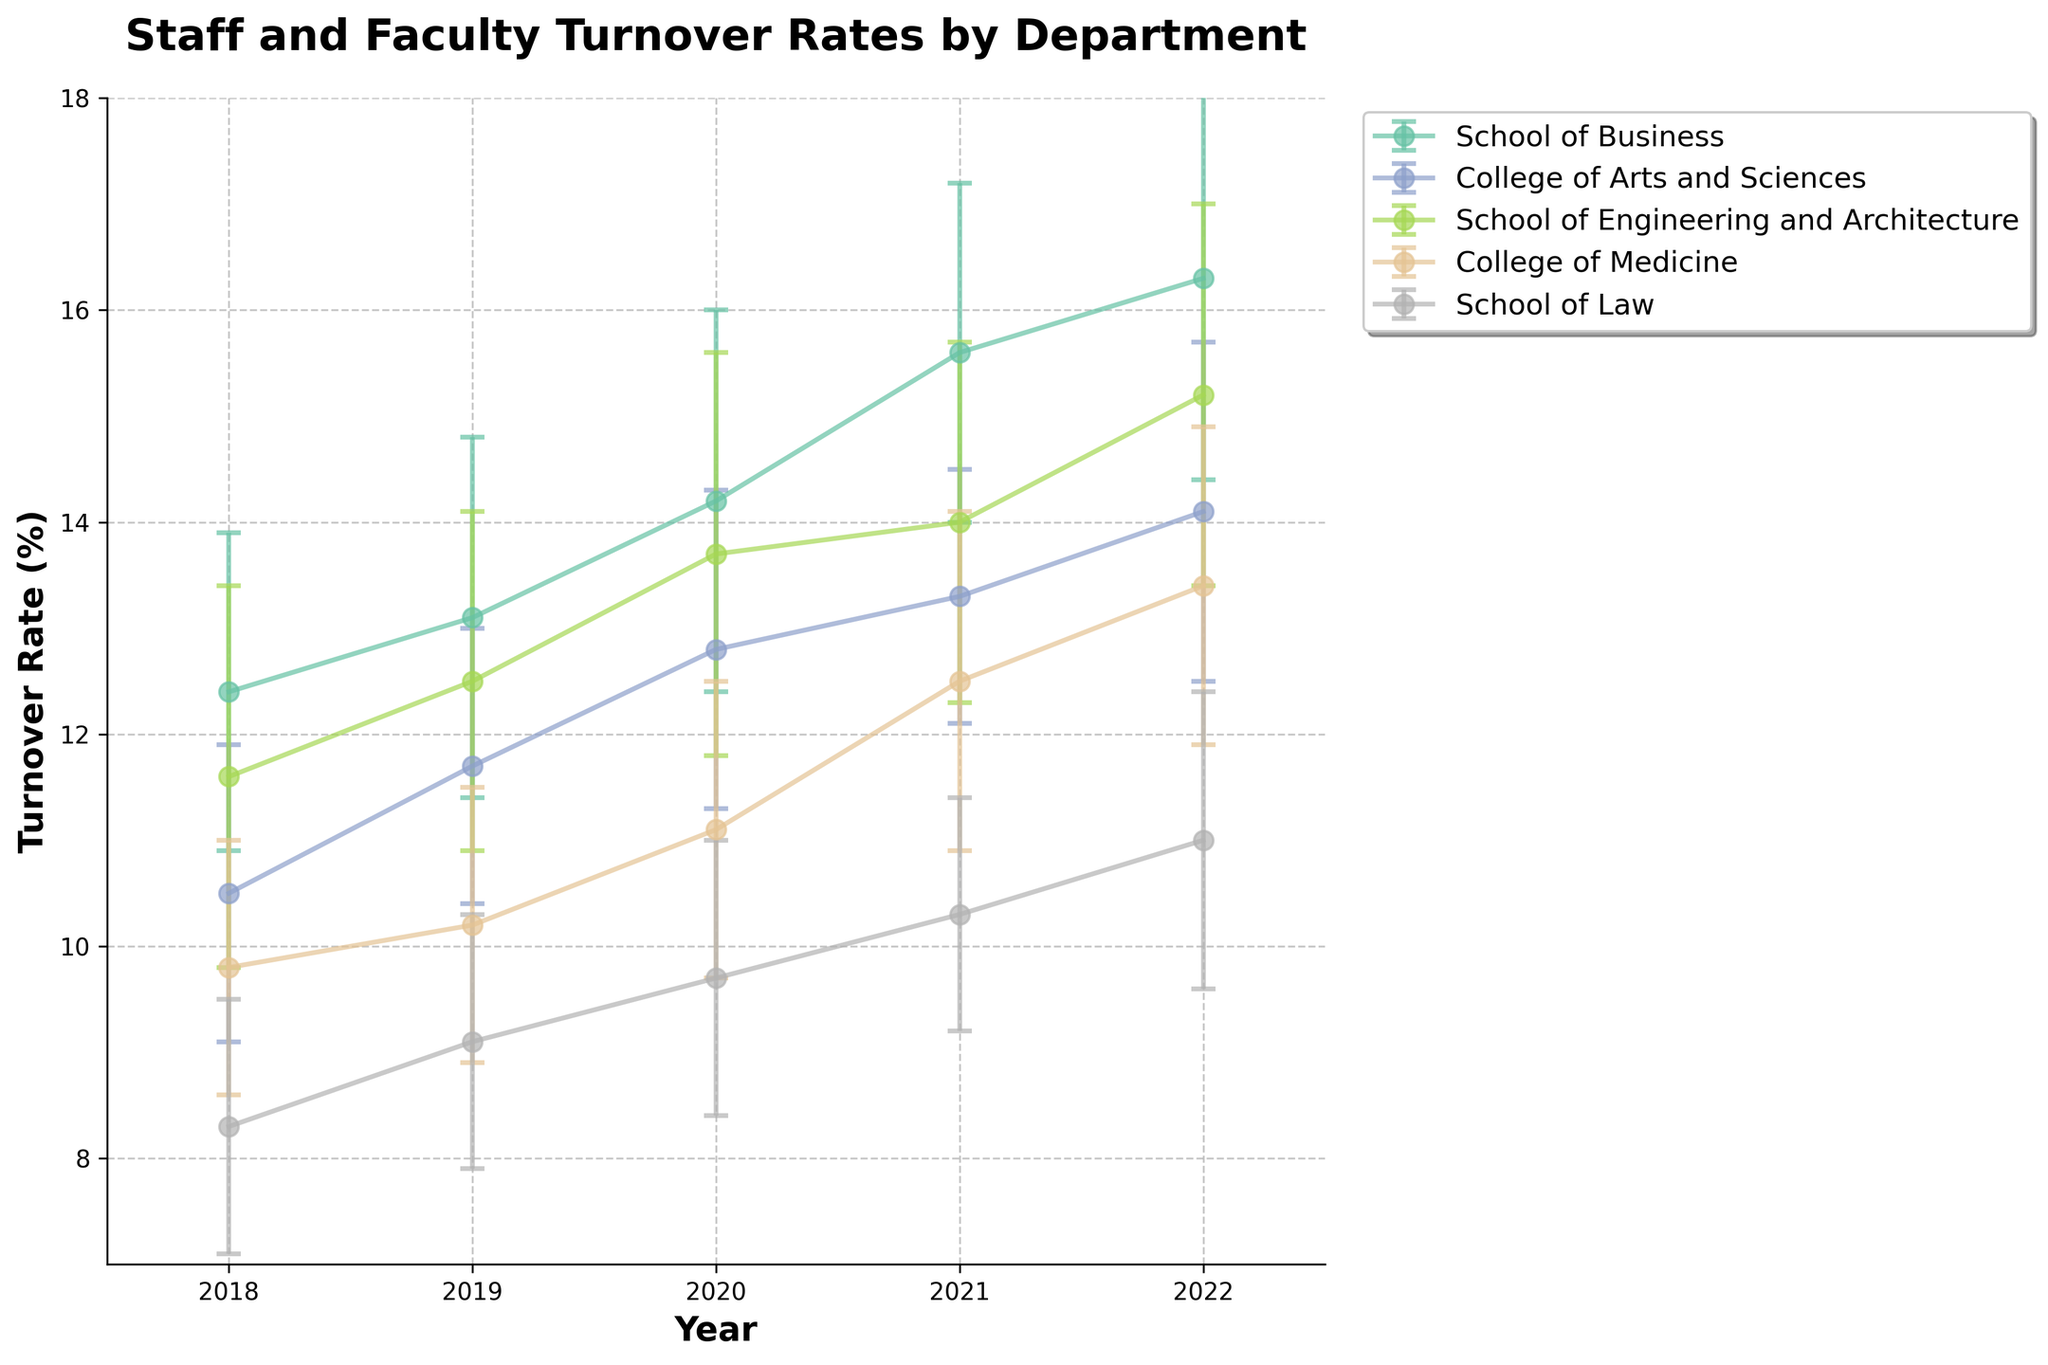What is the title of the figure? The title is displayed at the top of the figure, usually formatted in a larger and bolder font than other text
Answer: Staff and Faculty Turnover Rates by Department Which department had the lowest turnover rate in 2022? By visually inspecting the plot, observe each department's turnover rate for the year 2022
Answer: School of Law How does the turnover rate change for the School of Business from 2018 to 2022? By looking at the plot, identify the turnover rate values for the School of Business between 2018 and 2022 and note the trend
Answer: The turnover rate increases from 12.4% to 16.3% What is the general trend in turnover rates for all departments from 2018 to 2022? Check each department's turnover rates across the years, note the pattern and summarize the general direction of the trend
Answer: Increasing Which department showed the most significant change in turnover rate between 2018 and 2022? Calculate the difference between the turnover rates for each department in 2018 and 2022, and compare them
Answer: School of Law In which year did the College of Medicine experience the largest jump in turnover rates? Compare the rate changes year by year for the College of Medicine and identify the largest increase
Answer: 2021 Compare the turnover rates of the College of Arts and Sciences and the School of Engineering and Architecture in 2020 and determine which had a higher rate. Check the turnover rates for both departments in 2020 and see which is higher
Answer: School of Engineering and Architecture What is the approximate average turnover rate for the School of Law from 2018 to 2022? Sum the turnover rates for the School of Law for each year and divide by the number of years
Answer: (8.3 + 9.1 + 9.7 + 10.3 + 11.0) / 5 ≈ 9.68% How do the standard deviations for the College of Arts and Sciences compare to those for the School of Business across the years? Compare the standard deviation error bars for both departments across the years, noting which are generally larger or smaller
Answer: Generally similar, with instances of School of Business being slightly larger Based on the error bars, which department shows the greatest variability in turnover rates over time? Look for the department with the largest average size of error bars across all years
Answer: Possibly the School of Engineering and Architecture 